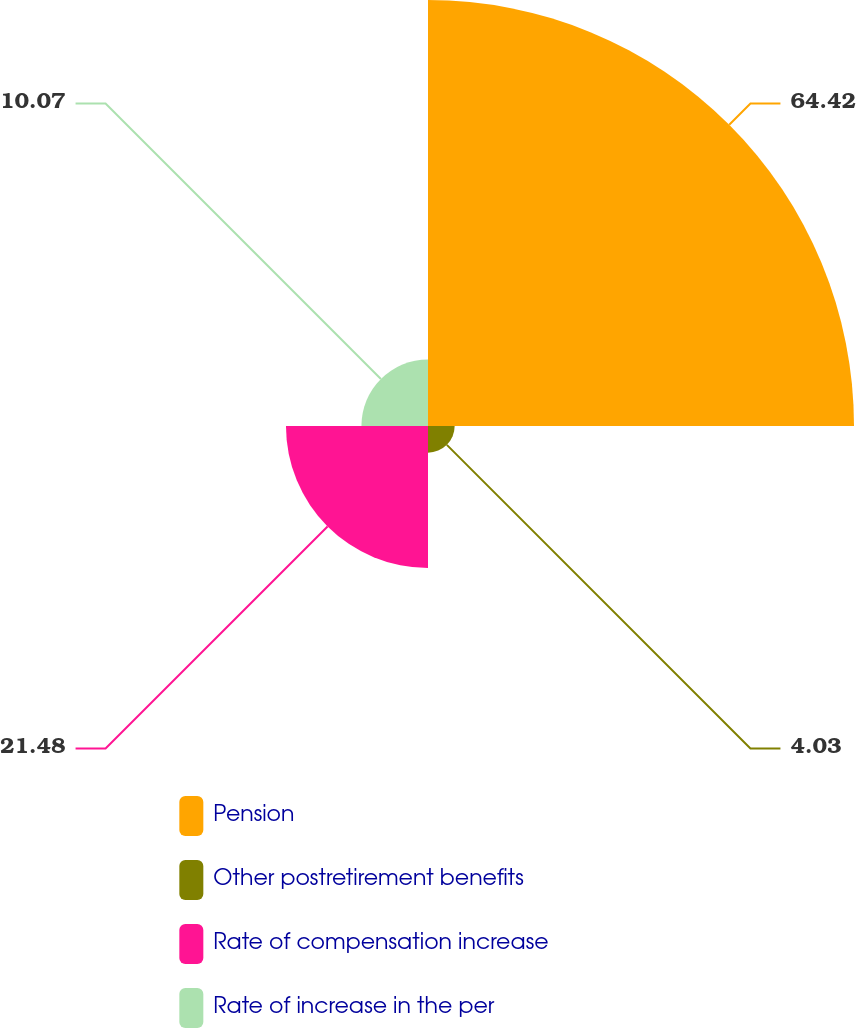Convert chart. <chart><loc_0><loc_0><loc_500><loc_500><pie_chart><fcel>Pension<fcel>Other postretirement benefits<fcel>Rate of compensation increase<fcel>Rate of increase in the per<nl><fcel>64.43%<fcel>4.03%<fcel>21.48%<fcel>10.07%<nl></chart> 